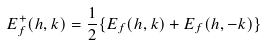<formula> <loc_0><loc_0><loc_500><loc_500>E _ { f } ^ { + } ( h , k ) = \frac { 1 } { 2 } \{ E _ { f } ( h , k ) + E _ { f } ( h , - k ) \}</formula> 